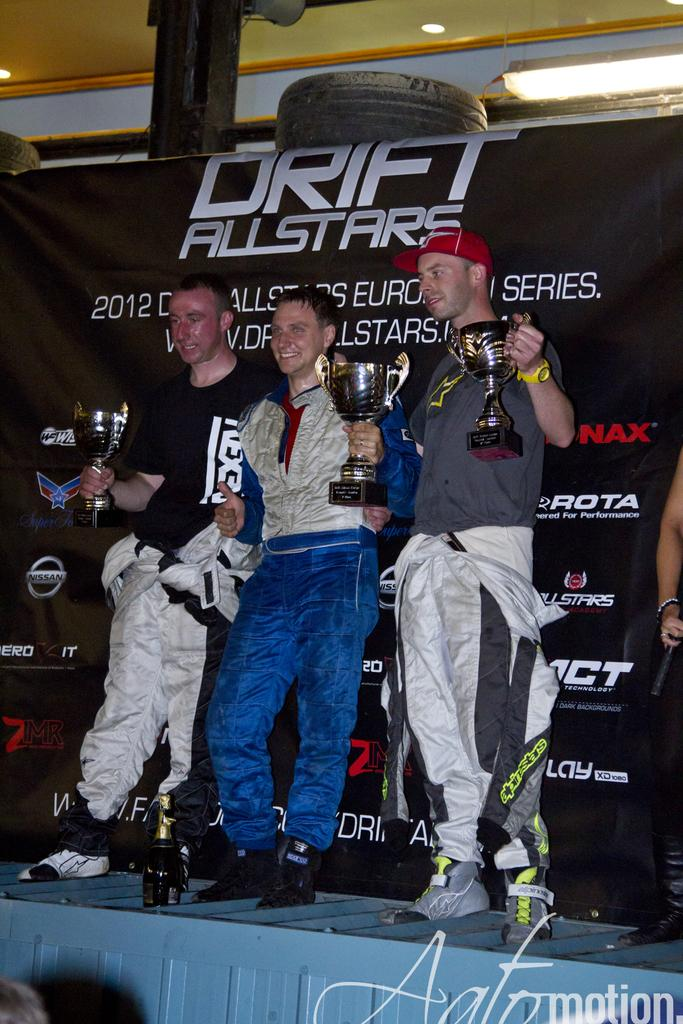<image>
Render a clear and concise summary of the photo. drift all stars lined up on a stage together 